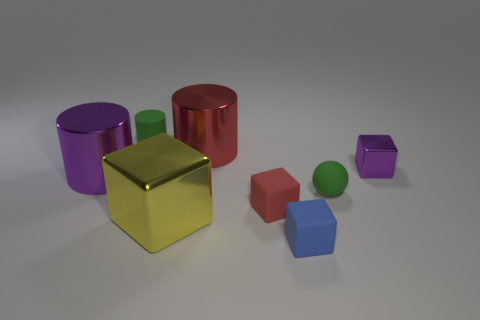Imagine these objects are part of a study on geometric shapes. Can you create a question relating to their arrangement? If we were to look at these objects as a part of a geometrical study, a relevant question might be: 'How does the spatial distribution of these varying geometric shapes influence the viewer's perception of depth and dimension in a composition?' That's interesting. Could you elaborate on how one's perception might be influenced? Certainly. The contrasting shapes and sizes create a dynamic visual field. The larger cylinders and cubes provide a sense of scale against the smaller cubes and sphere, while the reflective surfaces add complexity by revealing the environment and each other within their reflections, enriching the viewer's sense of space and dimensionality. 